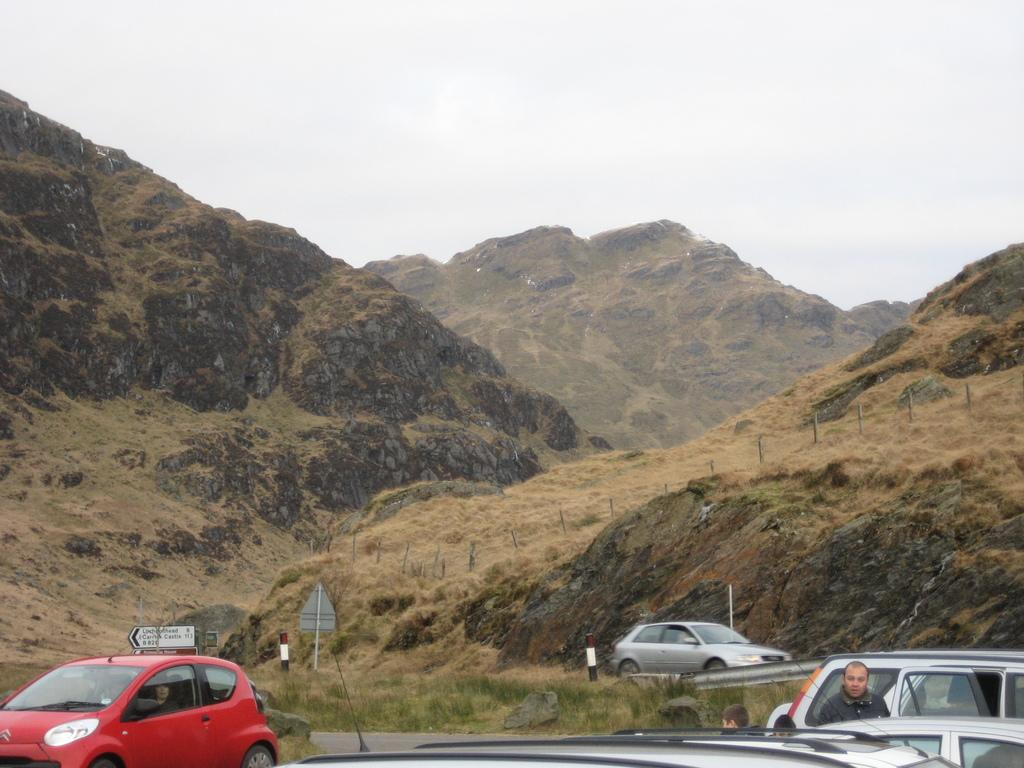What can be seen in the foreground area of the image? In the foreground area of the image, there are vehicles, small poles, a man, and grassland. Can you describe the man in the foreground area of the image? The man in the foreground area of the image is standing near the vehicles and small poles. What is visible in the background of the image? In the background of the image, there are mountains and sky. What is the name of the man in the image? The provided facts do not mention the name of the man in the image. Can you tell me if the image has a sense of urgency? The image does not convey a sense of urgency, as there are no indications of any specific situation or event taking place. 